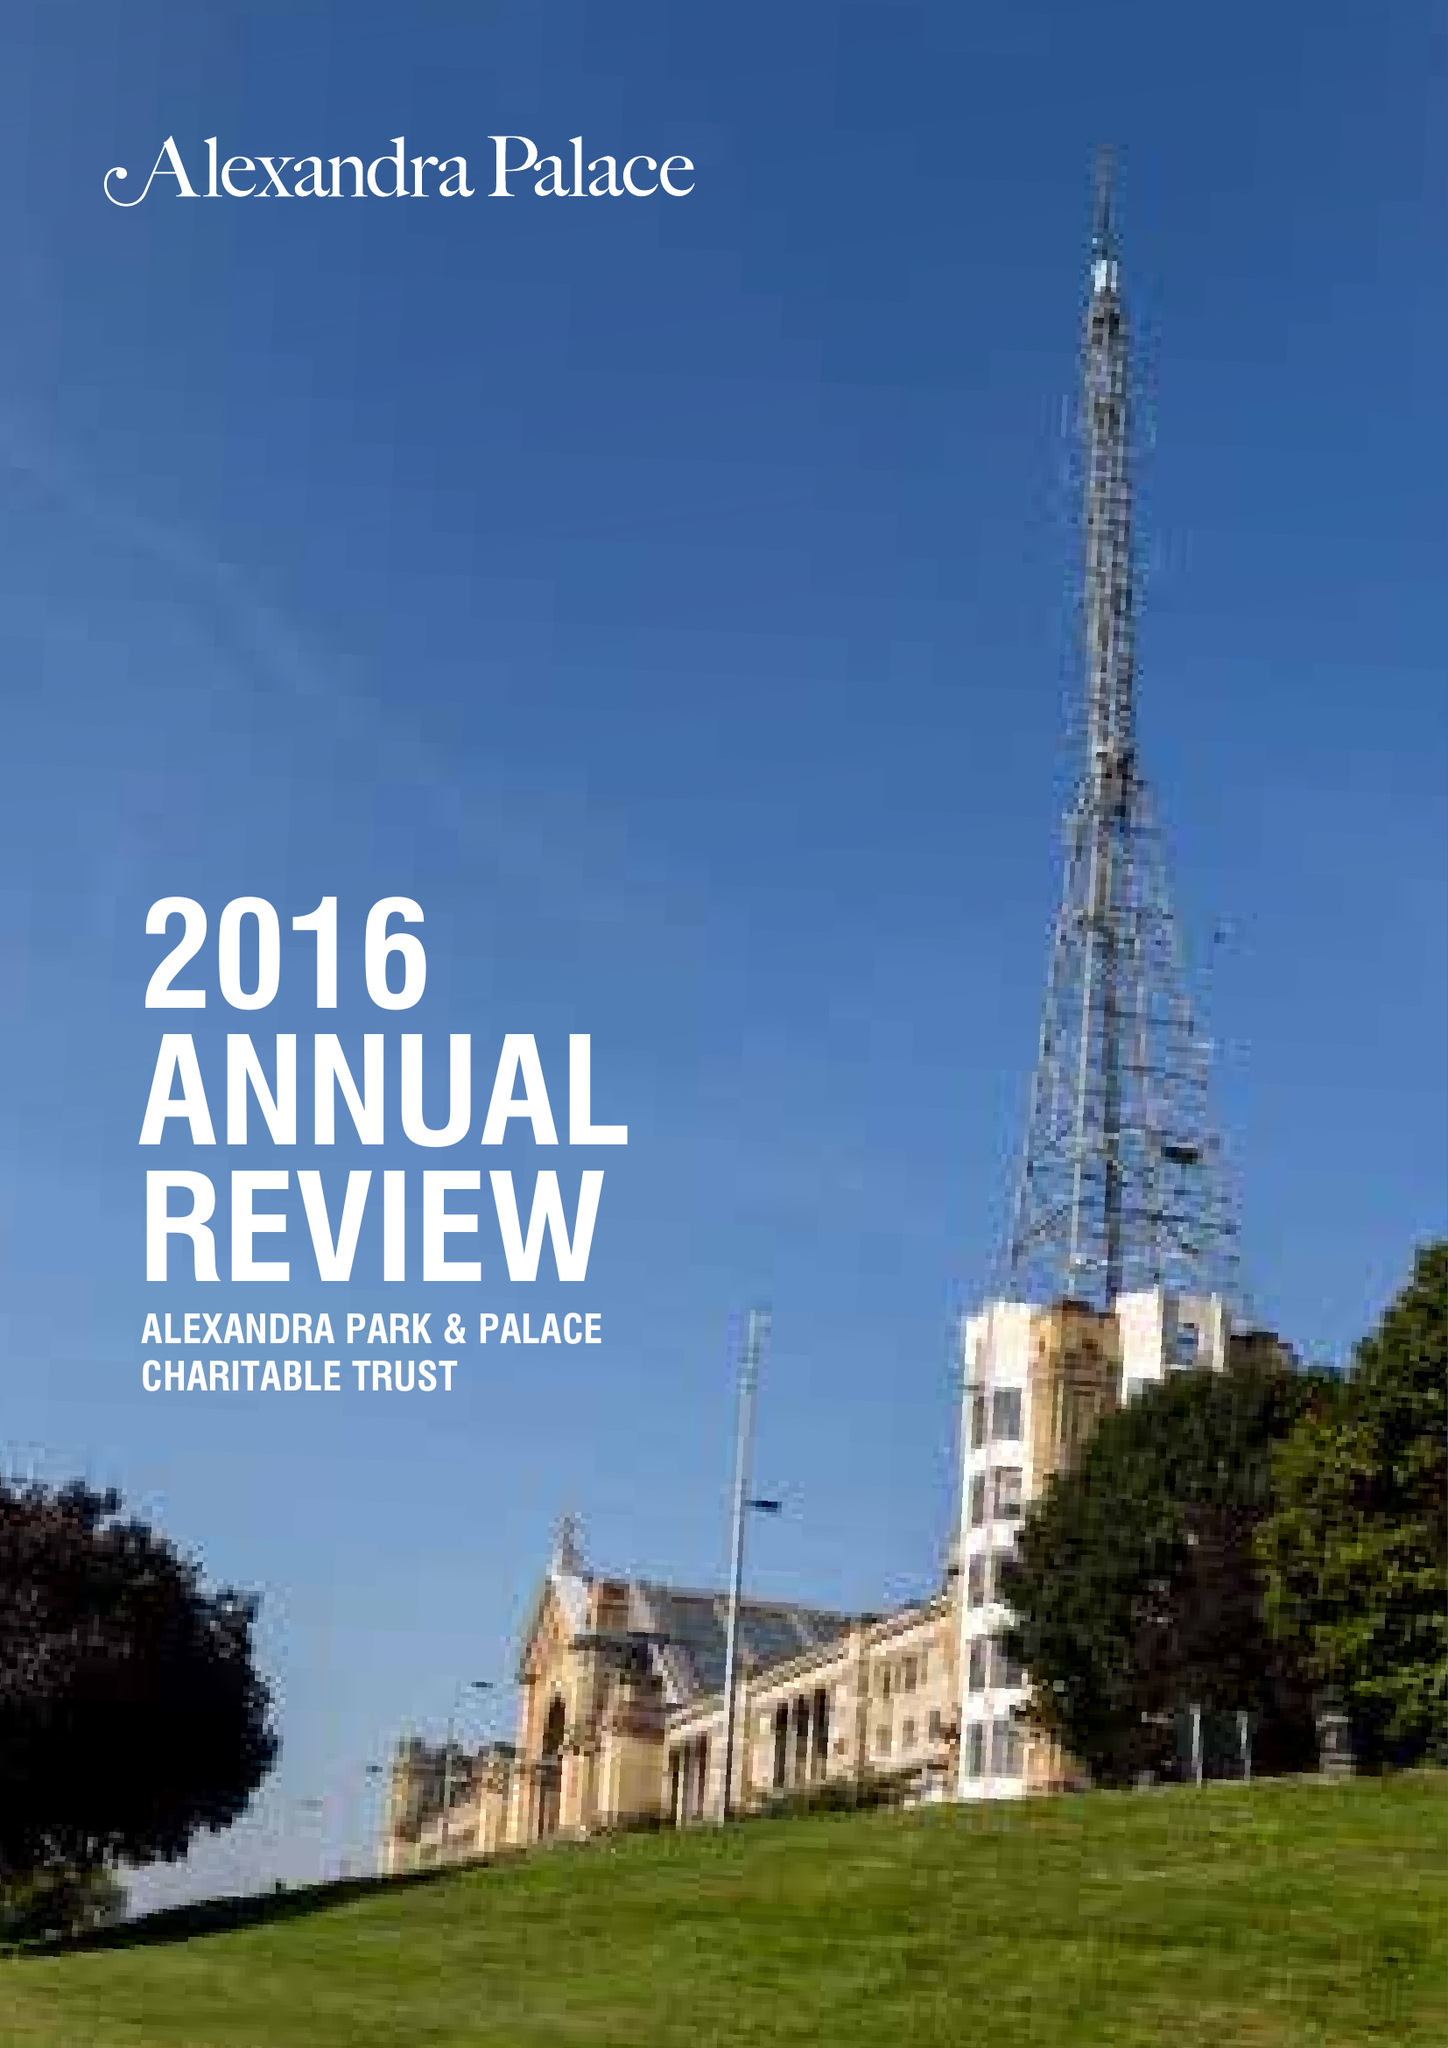What is the value for the charity_name?
Answer the question using a single word or phrase. Alexandra Park and Palace 